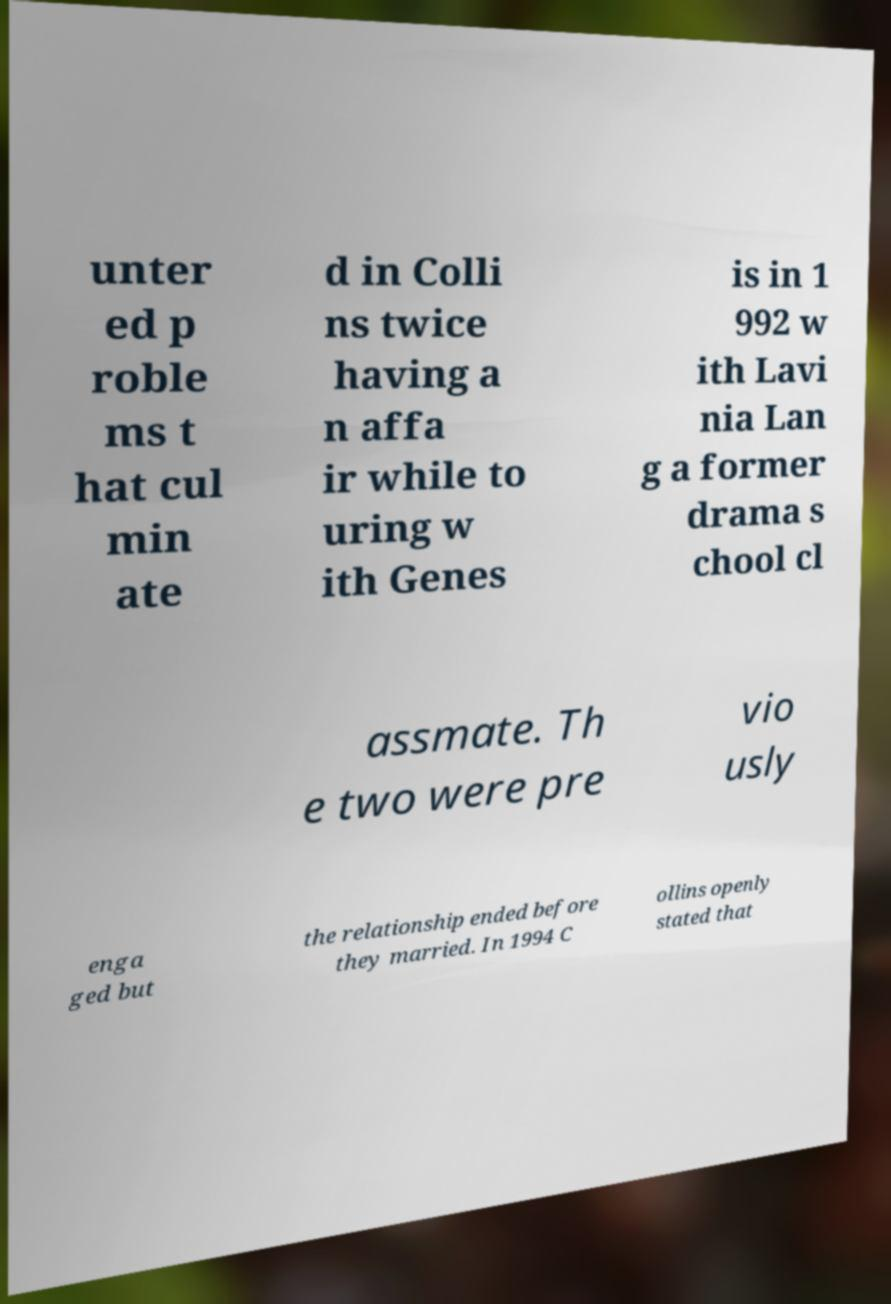For documentation purposes, I need the text within this image transcribed. Could you provide that? unter ed p roble ms t hat cul min ate d in Colli ns twice having a n affa ir while to uring w ith Genes is in 1 992 w ith Lavi nia Lan g a former drama s chool cl assmate. Th e two were pre vio usly enga ged but the relationship ended before they married. In 1994 C ollins openly stated that 